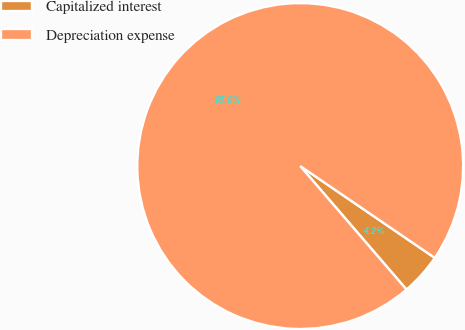Convert chart. <chart><loc_0><loc_0><loc_500><loc_500><pie_chart><fcel>Capitalized interest<fcel>Depreciation expense<nl><fcel>4.16%<fcel>95.84%<nl></chart> 